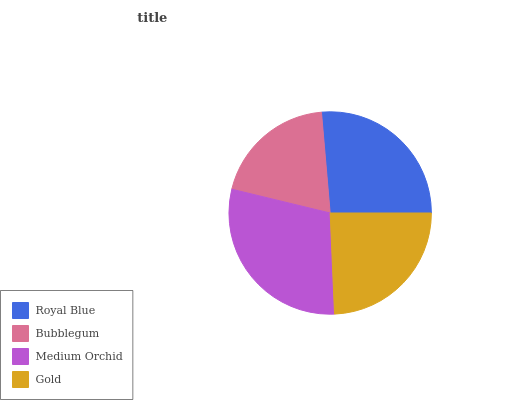Is Bubblegum the minimum?
Answer yes or no. Yes. Is Medium Orchid the maximum?
Answer yes or no. Yes. Is Medium Orchid the minimum?
Answer yes or no. No. Is Bubblegum the maximum?
Answer yes or no. No. Is Medium Orchid greater than Bubblegum?
Answer yes or no. Yes. Is Bubblegum less than Medium Orchid?
Answer yes or no. Yes. Is Bubblegum greater than Medium Orchid?
Answer yes or no. No. Is Medium Orchid less than Bubblegum?
Answer yes or no. No. Is Royal Blue the high median?
Answer yes or no. Yes. Is Gold the low median?
Answer yes or no. Yes. Is Gold the high median?
Answer yes or no. No. Is Medium Orchid the low median?
Answer yes or no. No. 